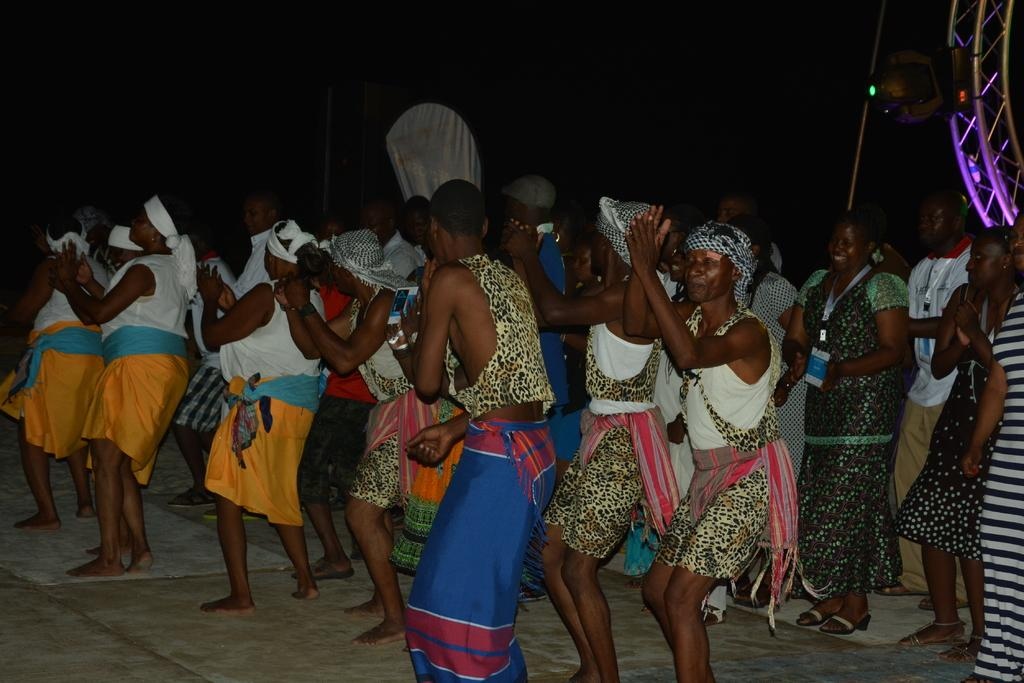What is happening in the image involving a group of people? The people in the image are dancing on the floor. What are some of the people wearing? Some of the people are wearing white tops. Can you describe the people towards the right side of the image? There are two women towards the right side of the image. What can be observed about the background of the image? The background of the image is dark. What type of machine is being used by the people in the image? There is no machine present in the image; the people are dancing on the floor. Can you tell me how many dolls are visible in the image? There are no dolls present in the image. 